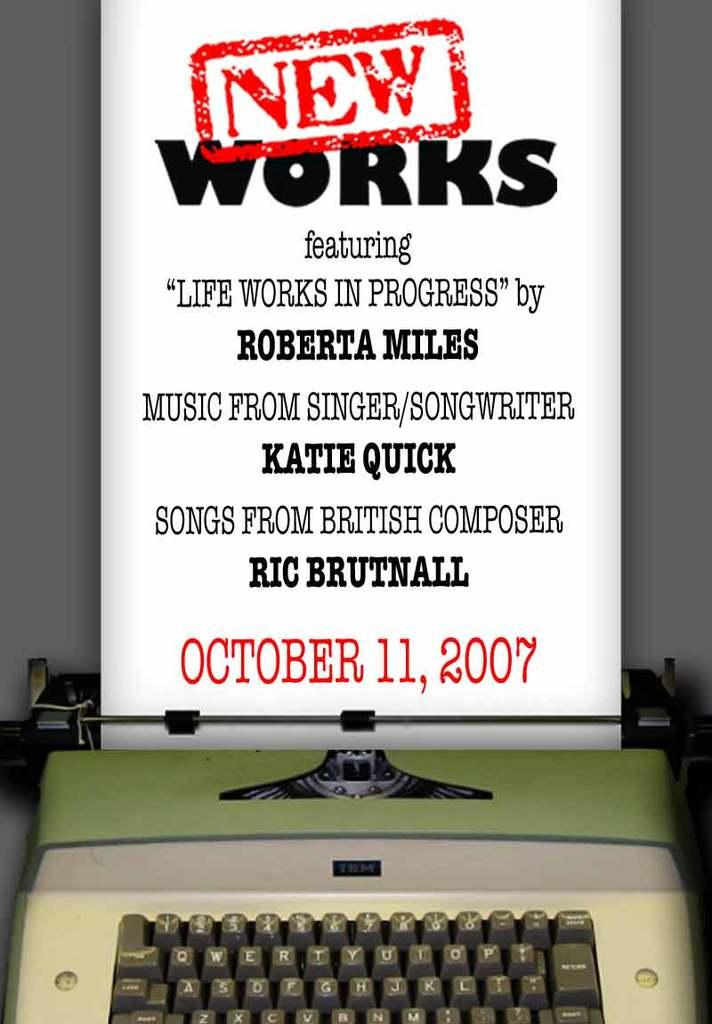<image>
Render a clear and concise summary of the photo. New Works comes out on October 11, 2017. 